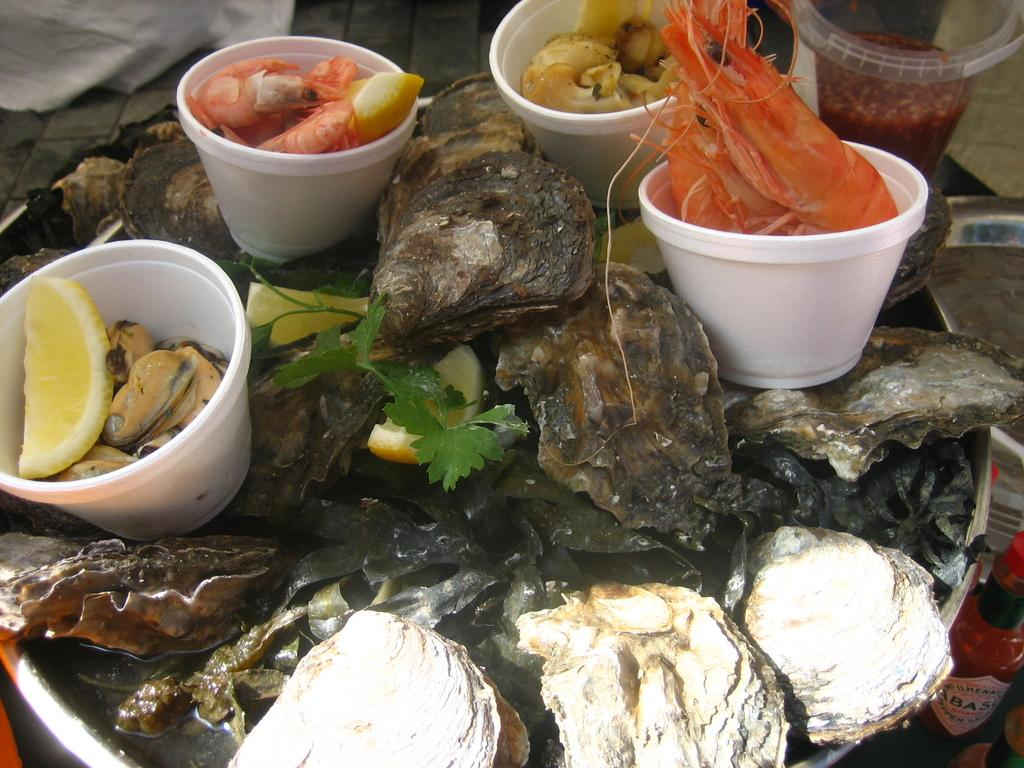What is present on the tray in the image? There is a tray in the image, and it has cups on it. What is inside the cups on the tray? The cups contain seafood items. What type of music can be heard coming from the sock in the image? There is no sock or music present in the image. 